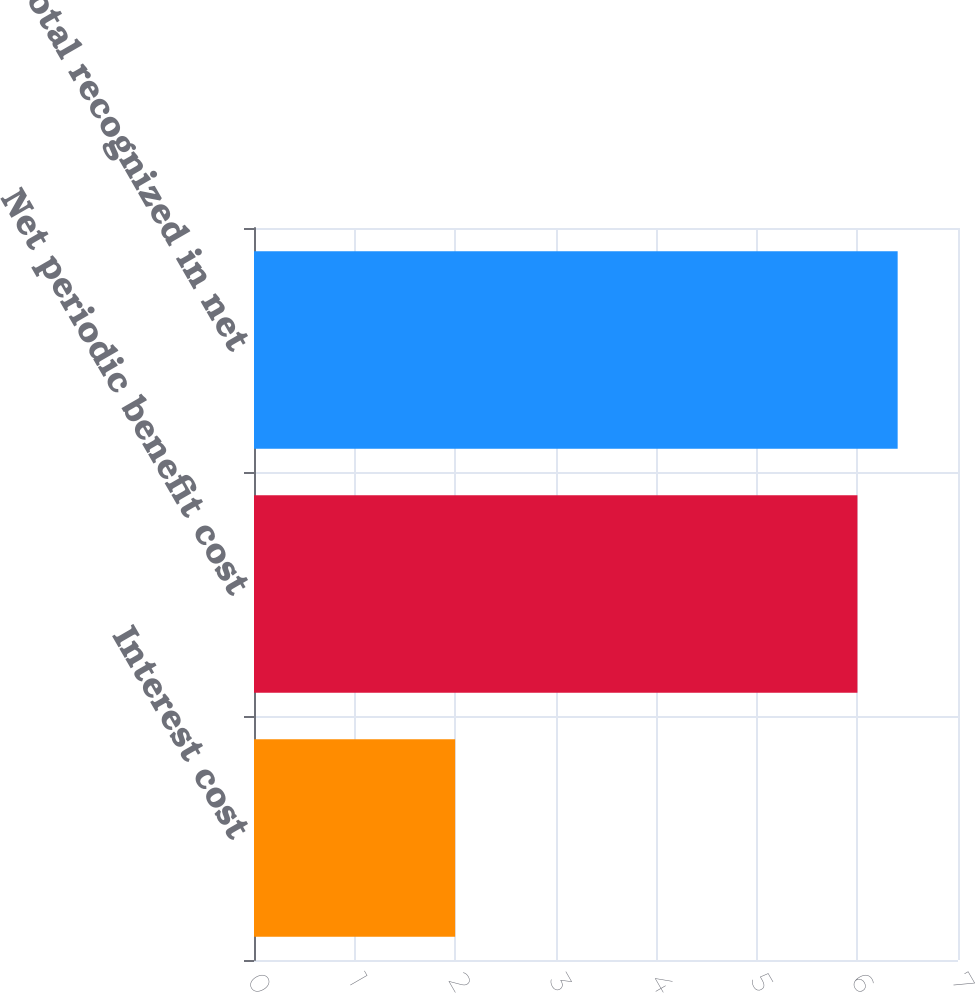Convert chart. <chart><loc_0><loc_0><loc_500><loc_500><bar_chart><fcel>Interest cost<fcel>Net periodic benefit cost<fcel>Total recognized in net<nl><fcel>2<fcel>6<fcel>6.4<nl></chart> 